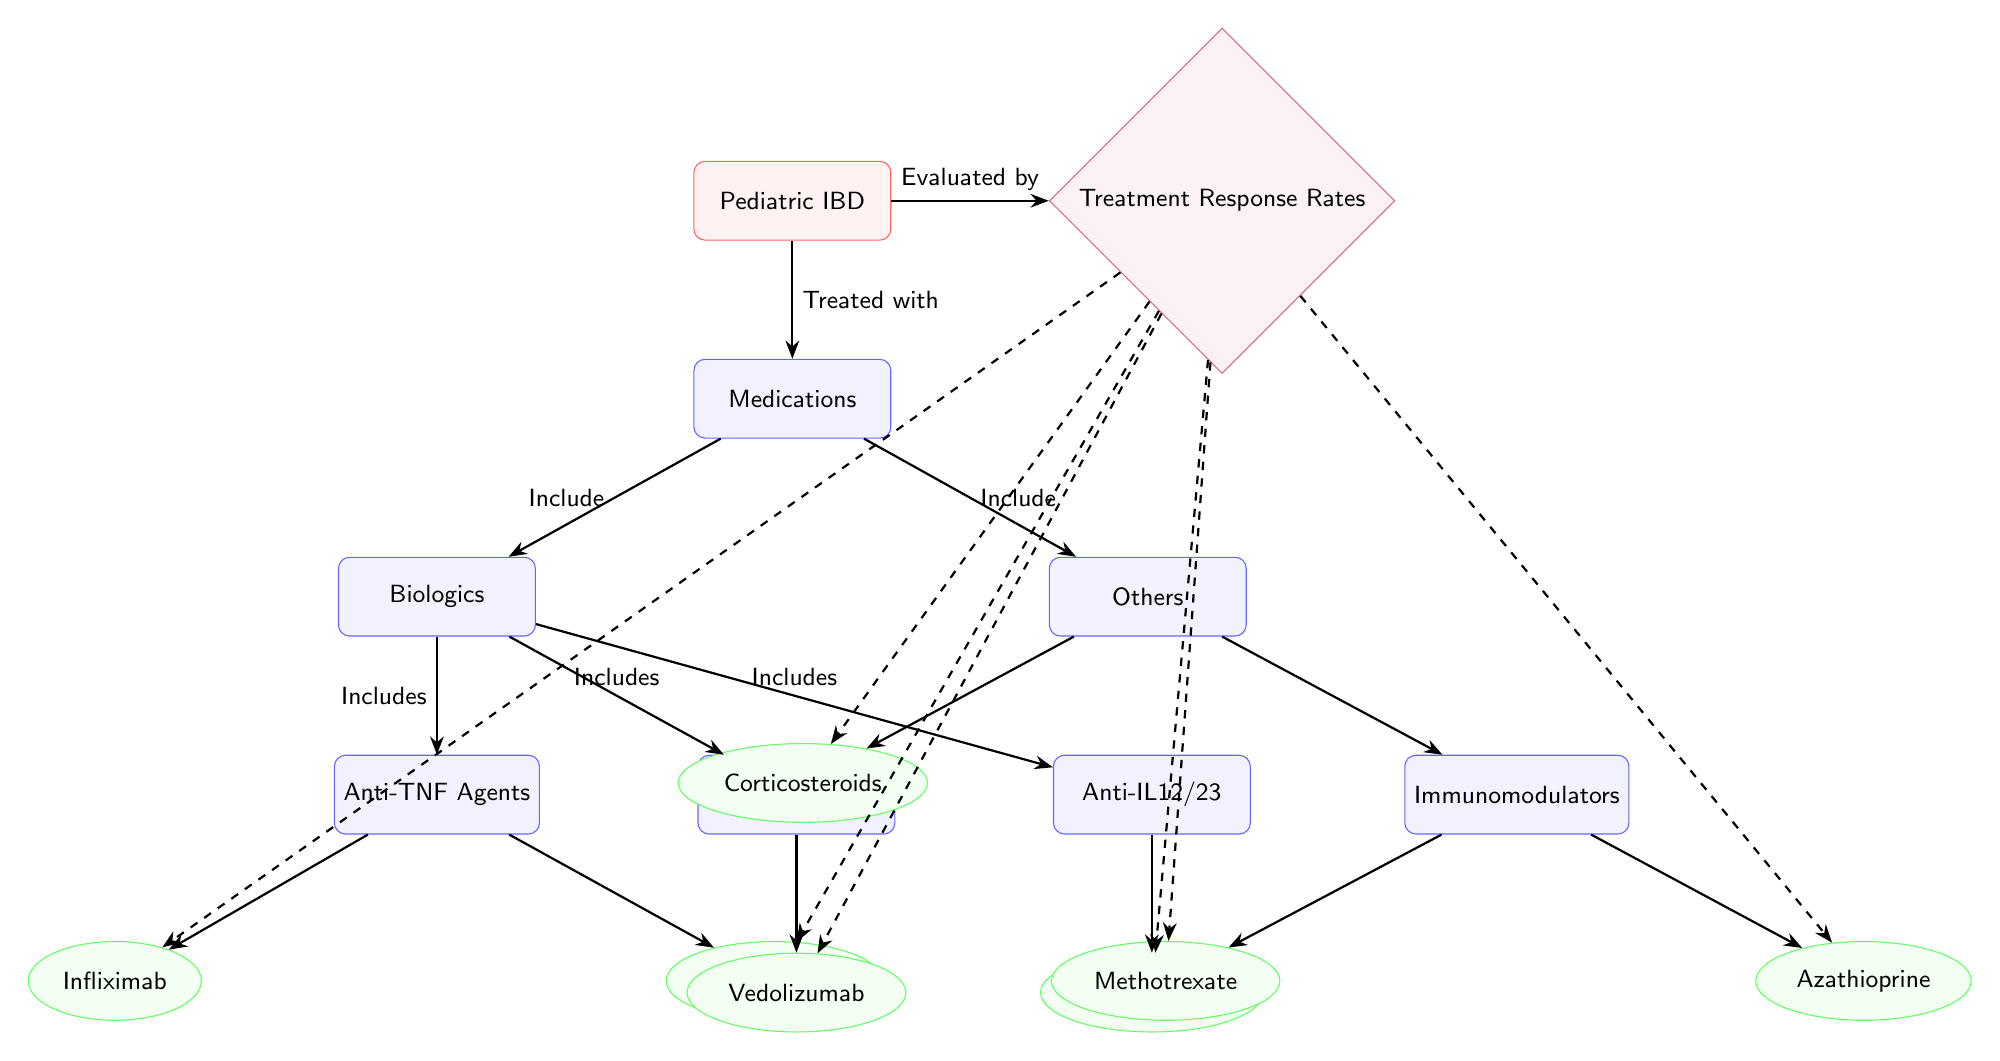What is the central disease represented in the diagram? The diagram starts with the node labeled "Pediatric IBD," indicating that this is the main focus of treatment.
Answer: Pediatric IBD How many categories of medications are included in the diagram? The diagram shows two main categories under "Medications": "Biologics" and "Others," totaling two categories.
Answer: 2 Which medication falls under the Anti-TNF Agents category? Under the "Anti-TNF Agents" node, the medications "Infliximab" and "Adalimumab" are included, with either being a valid answer.
Answer: Infliximab or Adalimumab What arrows connect "Pediatric IBD" and "Treatment Response Rates"? There is a single arrow connecting "Pediatric IBD" to "Treatment Response Rates," indicating an evaluative relationship.
Answer: Evaluated by Which medication category includes "Ustekinumab"? "Ustekinumab" is linked under the "Anti-IL12/23" category, which is a subset of "Biologics."
Answer: Anti-IL12/23 How many medications are evaluated under the treatment response? The diagram lists six medications as being evaluated: Infliximab, Adalimumab, Vedolizumab, Ustekinumab, Corticosteroids, Methotrexate, and Azathioprine, resulting in a total of six.
Answer: 6 What type of medications are included under "Immunomodulators"? The node "Immunomodulators" lists "Methotrexate" and "Azathioprine," which are both types of immunomodulatory medications.
Answer: Methotrexate and Azathioprine Which medication is categorized as a corticosteroid? The node labeled "Corticosteroids" specifically names "Corticosteroids" as the medication, making it identifiable.
Answer: Corticosteroids What relationship is indicated between "Medications" and "Biologics"? The arrow labeled "Include" connects the two, indicating that biologics are part of the broader category of medications being considered.
Answer: Include 